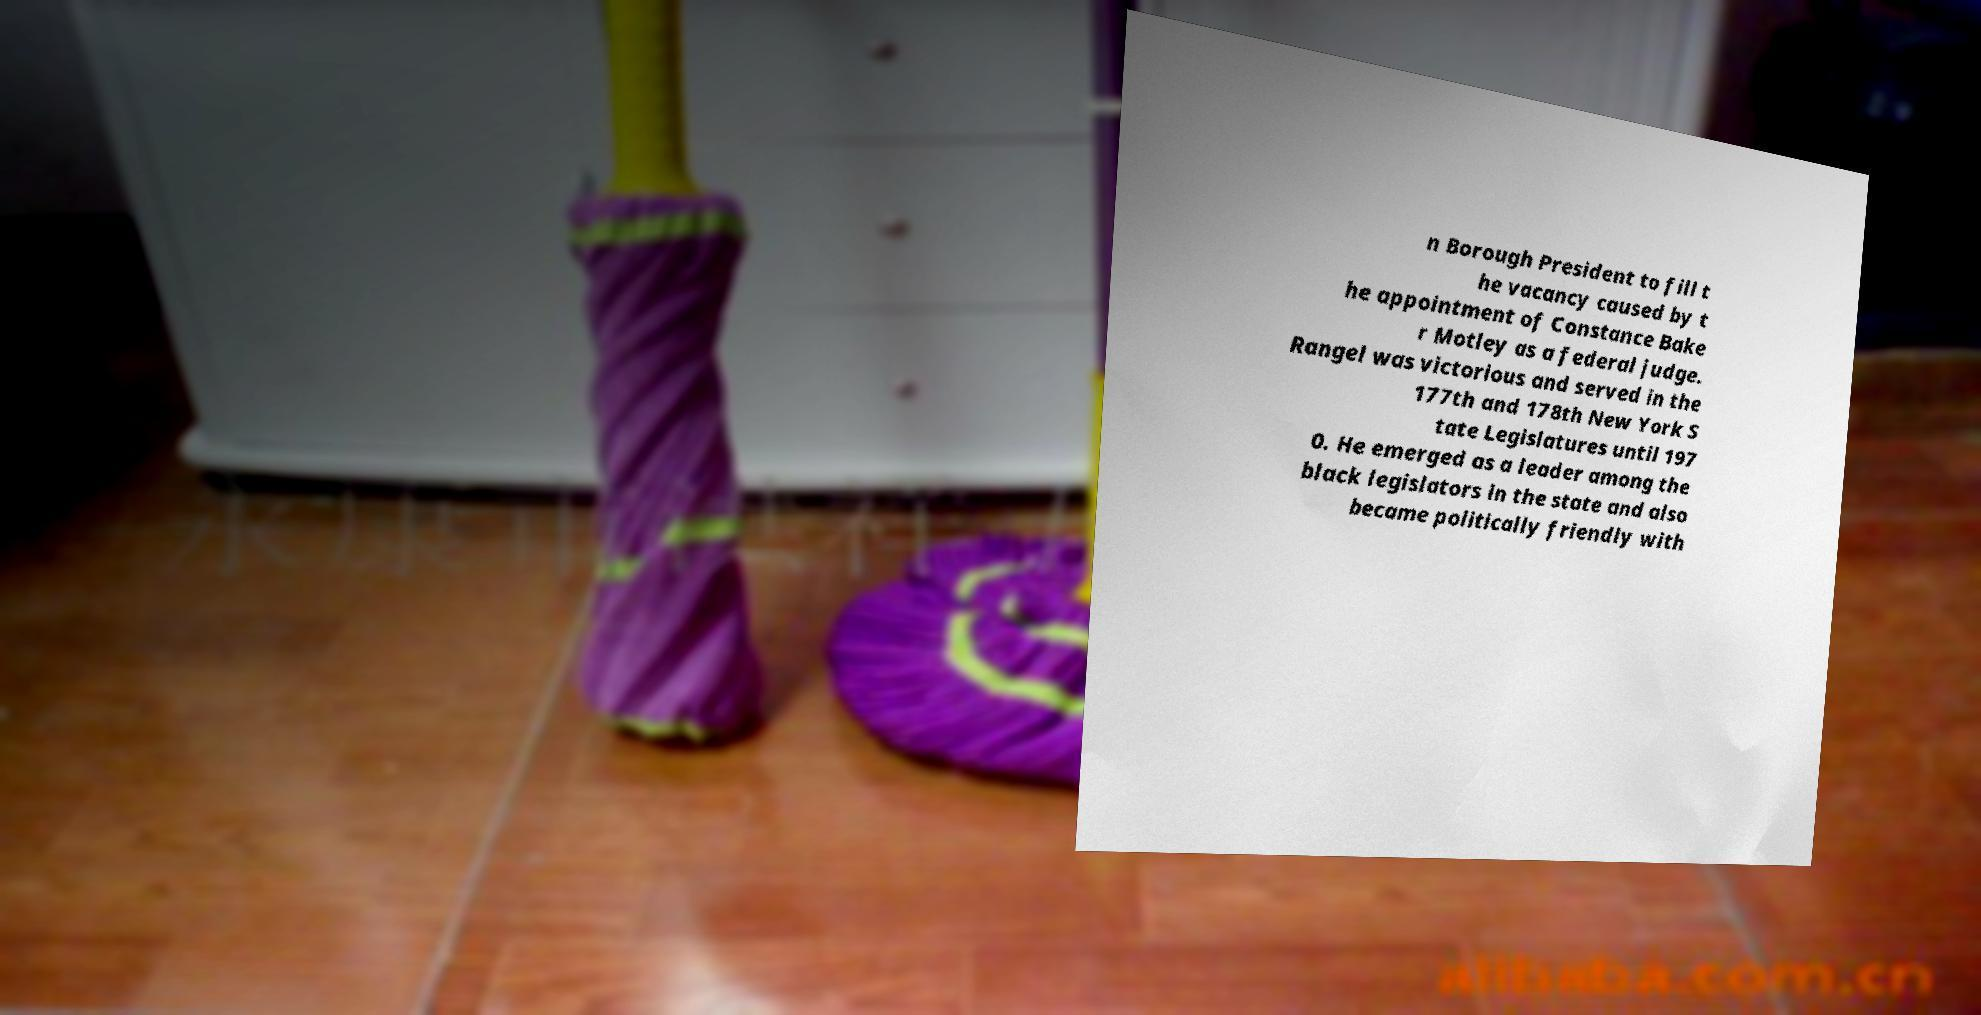Can you read and provide the text displayed in the image?This photo seems to have some interesting text. Can you extract and type it out for me? n Borough President to fill t he vacancy caused by t he appointment of Constance Bake r Motley as a federal judge. Rangel was victorious and served in the 177th and 178th New York S tate Legislatures until 197 0. He emerged as a leader among the black legislators in the state and also became politically friendly with 